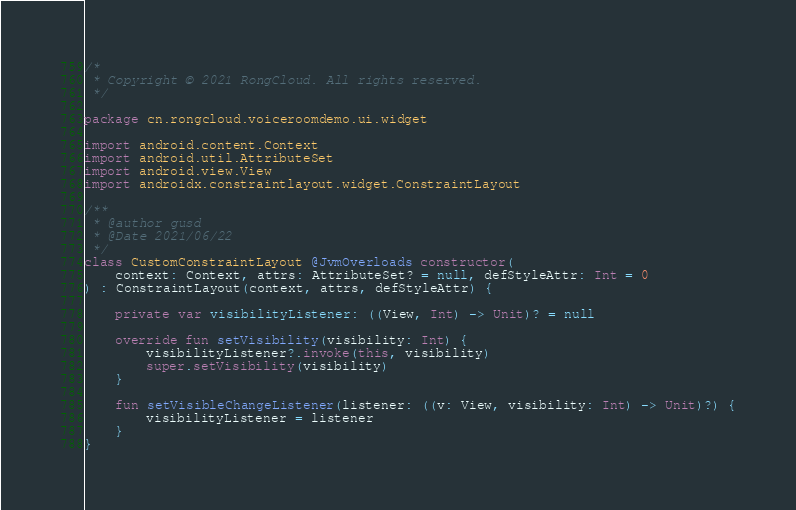Convert code to text. <code><loc_0><loc_0><loc_500><loc_500><_Kotlin_>/*
 * Copyright © 2021 RongCloud. All rights reserved.
 */

package cn.rongcloud.voiceroomdemo.ui.widget

import android.content.Context
import android.util.AttributeSet
import android.view.View
import androidx.constraintlayout.widget.ConstraintLayout

/**
 * @author gusd
 * @Date 2021/06/22
 */
class CustomConstraintLayout @JvmOverloads constructor(
    context: Context, attrs: AttributeSet? = null, defStyleAttr: Int = 0
) : ConstraintLayout(context, attrs, defStyleAttr) {

    private var visibilityListener: ((View, Int) -> Unit)? = null

    override fun setVisibility(visibility: Int) {
        visibilityListener?.invoke(this, visibility)
        super.setVisibility(visibility)
    }

    fun setVisibleChangeListener(listener: ((v: View, visibility: Int) -> Unit)?) {
        visibilityListener = listener
    }
}</code> 